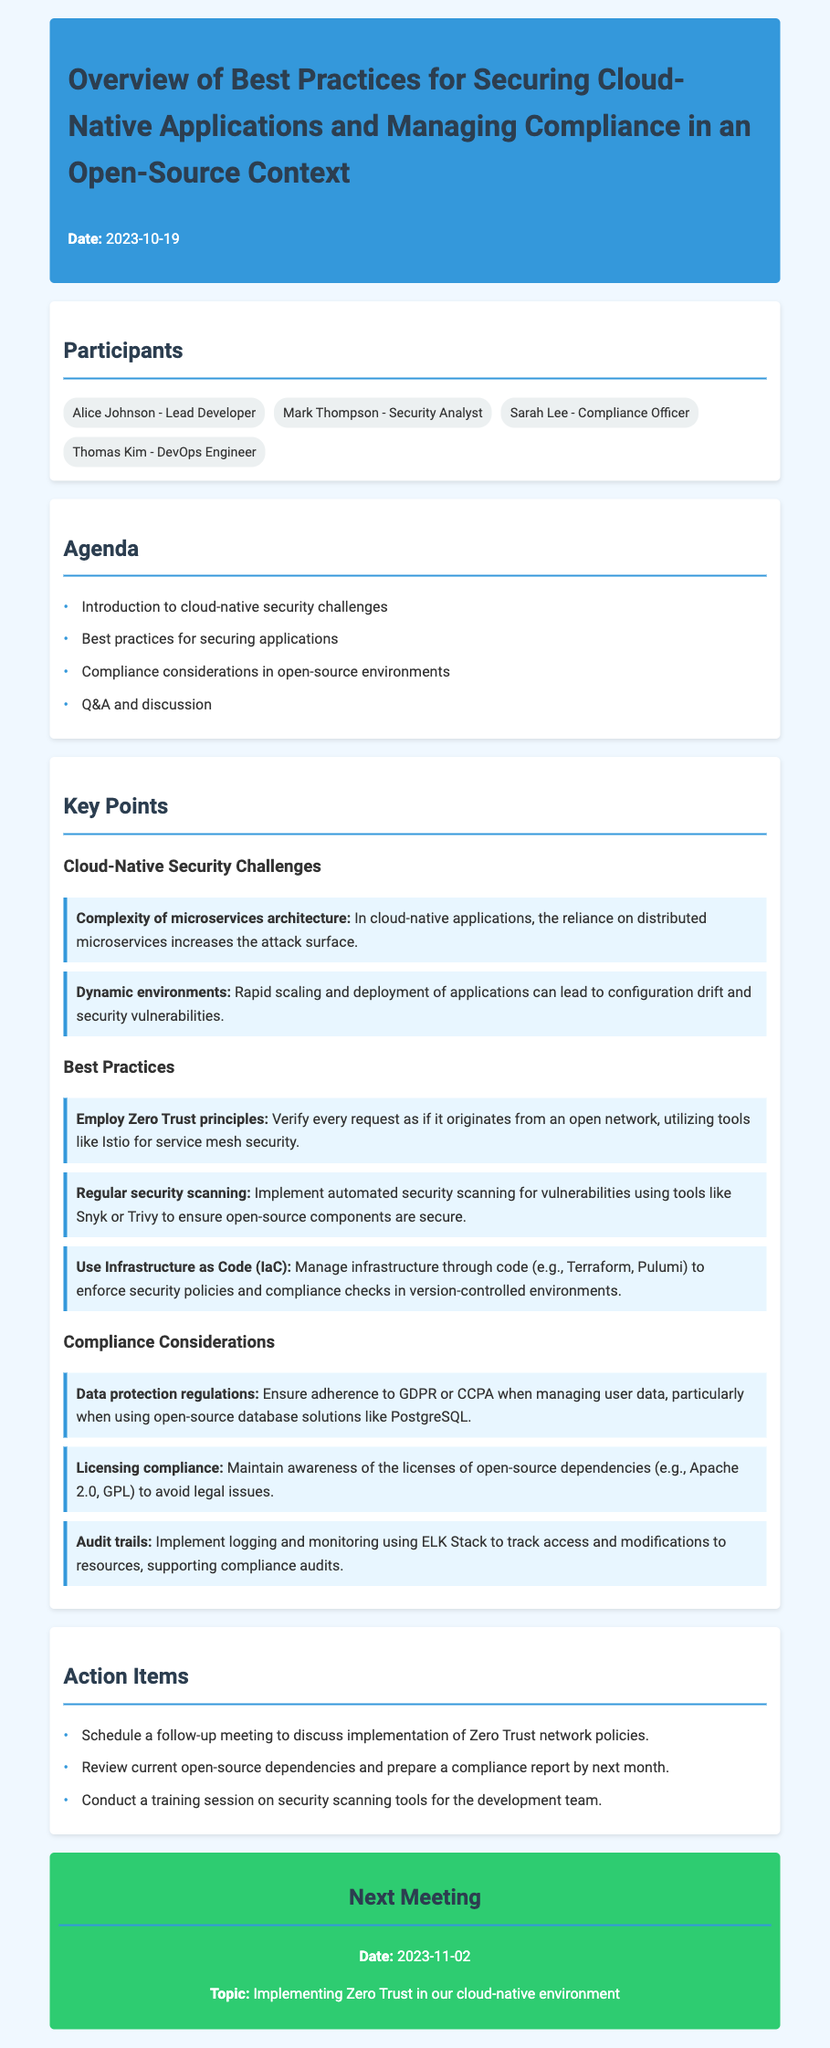What is the date of the meeting? The date of the meeting is explicitly stated at the beginning of the document.
Answer: 2023-10-19 Who is the compliance officer? The document lists the participants, identifying each person's role.
Answer: Sarah Lee What is one best practice mentioned for securing applications? The key points section lists several best practices for securing applications in cloud-native contexts.
Answer: Employ Zero Trust principles What are the data protection regulations mentioned? The key points section on compliance considerations specifies relevant regulations regarding data protection.
Answer: GDPR or CCPA How many action items were listed? The document includes a section that enumerates the action items to be addressed following the meeting.
Answer: 3 What is the next meeting date? The next meeting details are presented towards the end of the document.
Answer: 2023-11-02 What tool is suggested for regular security scanning? The best practices section highlights specific tools that can be used for automated security scanning.
Answer: Snyk or Trivy What is one compliance consideration regarding open-source dependencies? The compliance considerations section identifies issues related to licensing compliance for open-source dependencies.
Answer: Licensing compliance 